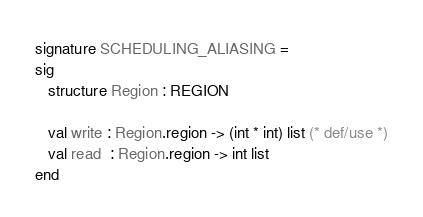<code> <loc_0><loc_0><loc_500><loc_500><_SML_>signature SCHEDULING_ALIASING =
sig
   structure Region : REGION

   val write : Region.region -> (int * int) list (* def/use *)
   val read  : Region.region -> int list
end
</code> 